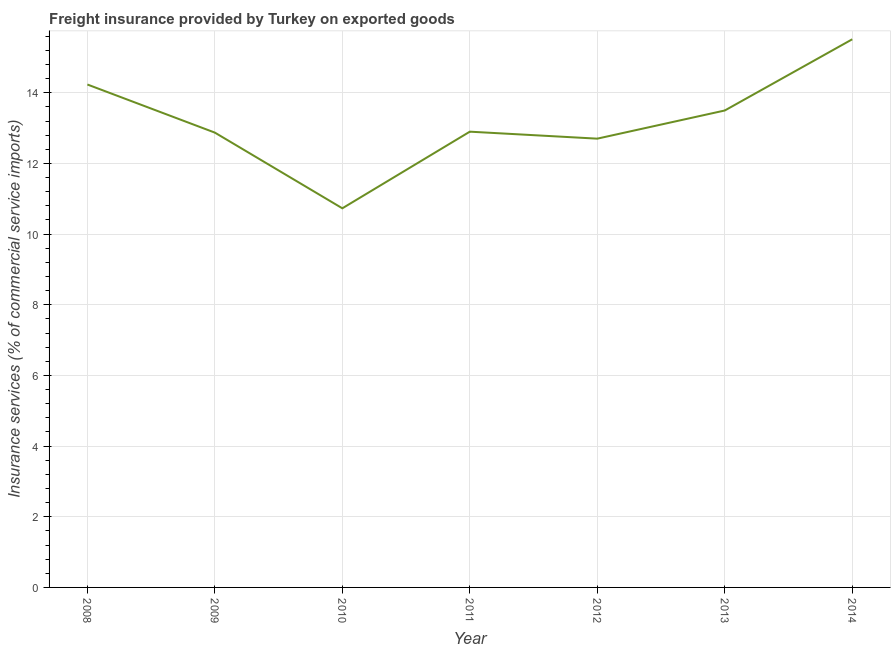What is the freight insurance in 2008?
Keep it short and to the point. 14.23. Across all years, what is the maximum freight insurance?
Offer a very short reply. 15.51. Across all years, what is the minimum freight insurance?
Provide a short and direct response. 10.73. In which year was the freight insurance maximum?
Make the answer very short. 2014. What is the sum of the freight insurance?
Offer a very short reply. 92.45. What is the difference between the freight insurance in 2009 and 2012?
Your response must be concise. 0.17. What is the average freight insurance per year?
Offer a very short reply. 13.21. What is the median freight insurance?
Make the answer very short. 12.9. In how many years, is the freight insurance greater than 10.4 %?
Provide a short and direct response. 7. What is the ratio of the freight insurance in 2011 to that in 2013?
Make the answer very short. 0.96. Is the difference between the freight insurance in 2008 and 2011 greater than the difference between any two years?
Provide a short and direct response. No. What is the difference between the highest and the second highest freight insurance?
Offer a very short reply. 1.28. Is the sum of the freight insurance in 2009 and 2013 greater than the maximum freight insurance across all years?
Give a very brief answer. Yes. What is the difference between the highest and the lowest freight insurance?
Offer a terse response. 4.78. How many lines are there?
Make the answer very short. 1. Are the values on the major ticks of Y-axis written in scientific E-notation?
Give a very brief answer. No. Does the graph contain any zero values?
Offer a very short reply. No. Does the graph contain grids?
Ensure brevity in your answer.  Yes. What is the title of the graph?
Your response must be concise. Freight insurance provided by Turkey on exported goods . What is the label or title of the X-axis?
Give a very brief answer. Year. What is the label or title of the Y-axis?
Your answer should be very brief. Insurance services (% of commercial service imports). What is the Insurance services (% of commercial service imports) in 2008?
Ensure brevity in your answer.  14.23. What is the Insurance services (% of commercial service imports) in 2009?
Provide a short and direct response. 12.87. What is the Insurance services (% of commercial service imports) of 2010?
Your answer should be very brief. 10.73. What is the Insurance services (% of commercial service imports) in 2011?
Your answer should be compact. 12.9. What is the Insurance services (% of commercial service imports) of 2012?
Provide a short and direct response. 12.7. What is the Insurance services (% of commercial service imports) in 2013?
Ensure brevity in your answer.  13.5. What is the Insurance services (% of commercial service imports) in 2014?
Make the answer very short. 15.51. What is the difference between the Insurance services (% of commercial service imports) in 2008 and 2009?
Provide a succinct answer. 1.36. What is the difference between the Insurance services (% of commercial service imports) in 2008 and 2010?
Provide a succinct answer. 3.5. What is the difference between the Insurance services (% of commercial service imports) in 2008 and 2011?
Make the answer very short. 1.33. What is the difference between the Insurance services (% of commercial service imports) in 2008 and 2012?
Your answer should be very brief. 1.53. What is the difference between the Insurance services (% of commercial service imports) in 2008 and 2013?
Offer a terse response. 0.74. What is the difference between the Insurance services (% of commercial service imports) in 2008 and 2014?
Offer a very short reply. -1.28. What is the difference between the Insurance services (% of commercial service imports) in 2009 and 2010?
Offer a terse response. 2.14. What is the difference between the Insurance services (% of commercial service imports) in 2009 and 2011?
Your answer should be very brief. -0.03. What is the difference between the Insurance services (% of commercial service imports) in 2009 and 2012?
Your answer should be very brief. 0.17. What is the difference between the Insurance services (% of commercial service imports) in 2009 and 2013?
Give a very brief answer. -0.63. What is the difference between the Insurance services (% of commercial service imports) in 2009 and 2014?
Your response must be concise. -2.64. What is the difference between the Insurance services (% of commercial service imports) in 2010 and 2011?
Offer a terse response. -2.17. What is the difference between the Insurance services (% of commercial service imports) in 2010 and 2012?
Give a very brief answer. -1.97. What is the difference between the Insurance services (% of commercial service imports) in 2010 and 2013?
Give a very brief answer. -2.77. What is the difference between the Insurance services (% of commercial service imports) in 2010 and 2014?
Give a very brief answer. -4.78. What is the difference between the Insurance services (% of commercial service imports) in 2011 and 2012?
Offer a terse response. 0.2. What is the difference between the Insurance services (% of commercial service imports) in 2011 and 2013?
Provide a short and direct response. -0.6. What is the difference between the Insurance services (% of commercial service imports) in 2011 and 2014?
Provide a succinct answer. -2.62. What is the difference between the Insurance services (% of commercial service imports) in 2012 and 2013?
Your answer should be very brief. -0.8. What is the difference between the Insurance services (% of commercial service imports) in 2012 and 2014?
Offer a terse response. -2.81. What is the difference between the Insurance services (% of commercial service imports) in 2013 and 2014?
Your answer should be compact. -2.02. What is the ratio of the Insurance services (% of commercial service imports) in 2008 to that in 2009?
Provide a succinct answer. 1.11. What is the ratio of the Insurance services (% of commercial service imports) in 2008 to that in 2010?
Your response must be concise. 1.33. What is the ratio of the Insurance services (% of commercial service imports) in 2008 to that in 2011?
Your answer should be compact. 1.1. What is the ratio of the Insurance services (% of commercial service imports) in 2008 to that in 2012?
Ensure brevity in your answer.  1.12. What is the ratio of the Insurance services (% of commercial service imports) in 2008 to that in 2013?
Your response must be concise. 1.05. What is the ratio of the Insurance services (% of commercial service imports) in 2008 to that in 2014?
Ensure brevity in your answer.  0.92. What is the ratio of the Insurance services (% of commercial service imports) in 2009 to that in 2010?
Provide a short and direct response. 1.2. What is the ratio of the Insurance services (% of commercial service imports) in 2009 to that in 2012?
Your response must be concise. 1.01. What is the ratio of the Insurance services (% of commercial service imports) in 2009 to that in 2013?
Make the answer very short. 0.95. What is the ratio of the Insurance services (% of commercial service imports) in 2009 to that in 2014?
Provide a short and direct response. 0.83. What is the ratio of the Insurance services (% of commercial service imports) in 2010 to that in 2011?
Your response must be concise. 0.83. What is the ratio of the Insurance services (% of commercial service imports) in 2010 to that in 2012?
Your response must be concise. 0.84. What is the ratio of the Insurance services (% of commercial service imports) in 2010 to that in 2013?
Your answer should be very brief. 0.8. What is the ratio of the Insurance services (% of commercial service imports) in 2010 to that in 2014?
Give a very brief answer. 0.69. What is the ratio of the Insurance services (% of commercial service imports) in 2011 to that in 2013?
Give a very brief answer. 0.96. What is the ratio of the Insurance services (% of commercial service imports) in 2011 to that in 2014?
Your response must be concise. 0.83. What is the ratio of the Insurance services (% of commercial service imports) in 2012 to that in 2013?
Make the answer very short. 0.94. What is the ratio of the Insurance services (% of commercial service imports) in 2012 to that in 2014?
Your response must be concise. 0.82. What is the ratio of the Insurance services (% of commercial service imports) in 2013 to that in 2014?
Your answer should be very brief. 0.87. 